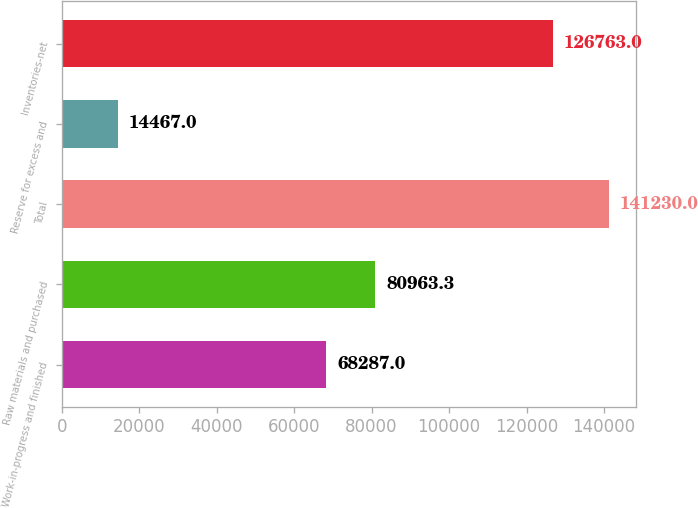Convert chart. <chart><loc_0><loc_0><loc_500><loc_500><bar_chart><fcel>Work-in-progress and finished<fcel>Raw materials and purchased<fcel>Total<fcel>Reserve for excess and<fcel>Inventories-net<nl><fcel>68287<fcel>80963.3<fcel>141230<fcel>14467<fcel>126763<nl></chart> 